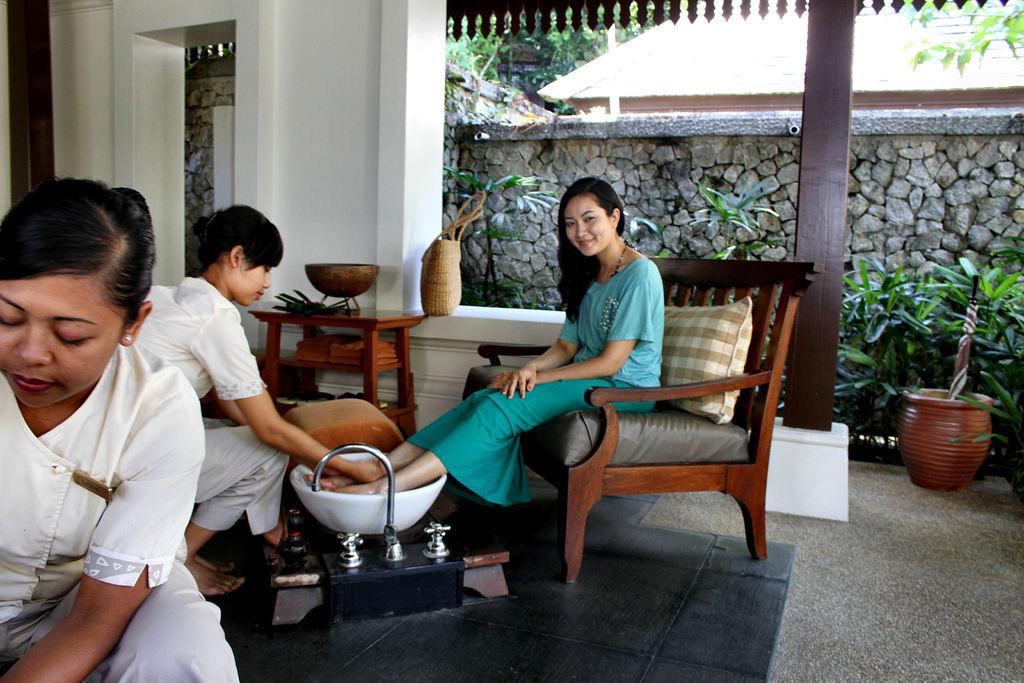Please provide a concise description of this image. It looks like a spa center here are three women, one woman is sitting on the chair and placing the feet in the wash basin another woman is washing her legs, the third woman is also doing some other work, we can see a table and a bowl on the table and a bag beside the table , in the background there are some plants, a pot, a pole and a wall rock wall and a house , trees. 